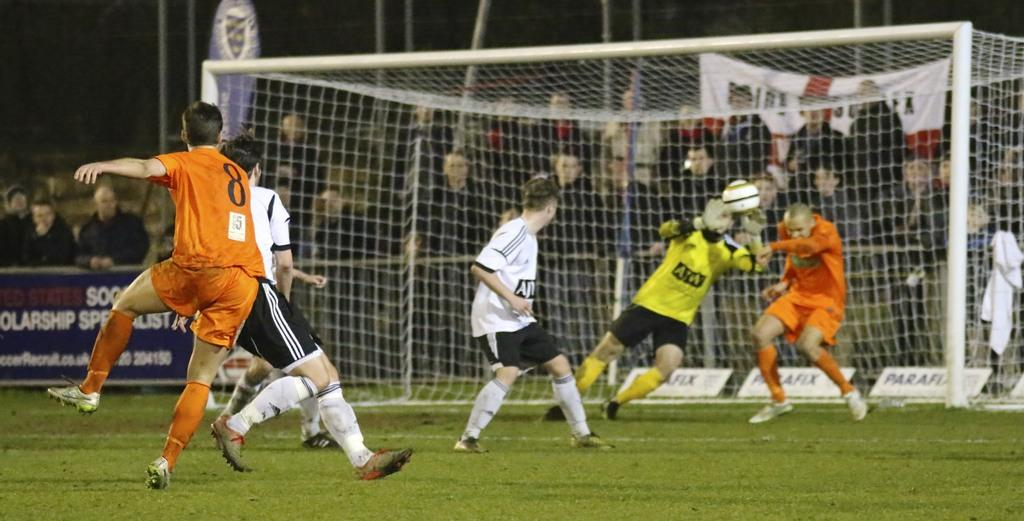What sport are the players engaged in within the image? The players are playing football. Where is the football game taking place? The football game is taking place on a ground. Who is present at the location besides the players? There are spectators around the ground. What are the spectators doing during the match? The spectators are watching the match. Can you describe the harbor visible in the image? There is no harbor present in the image; it features a football game taking place on a ground. How many times do the players shake hands during the match? The number of handshakes cannot be determined from the image, as it only shows the players in action. 